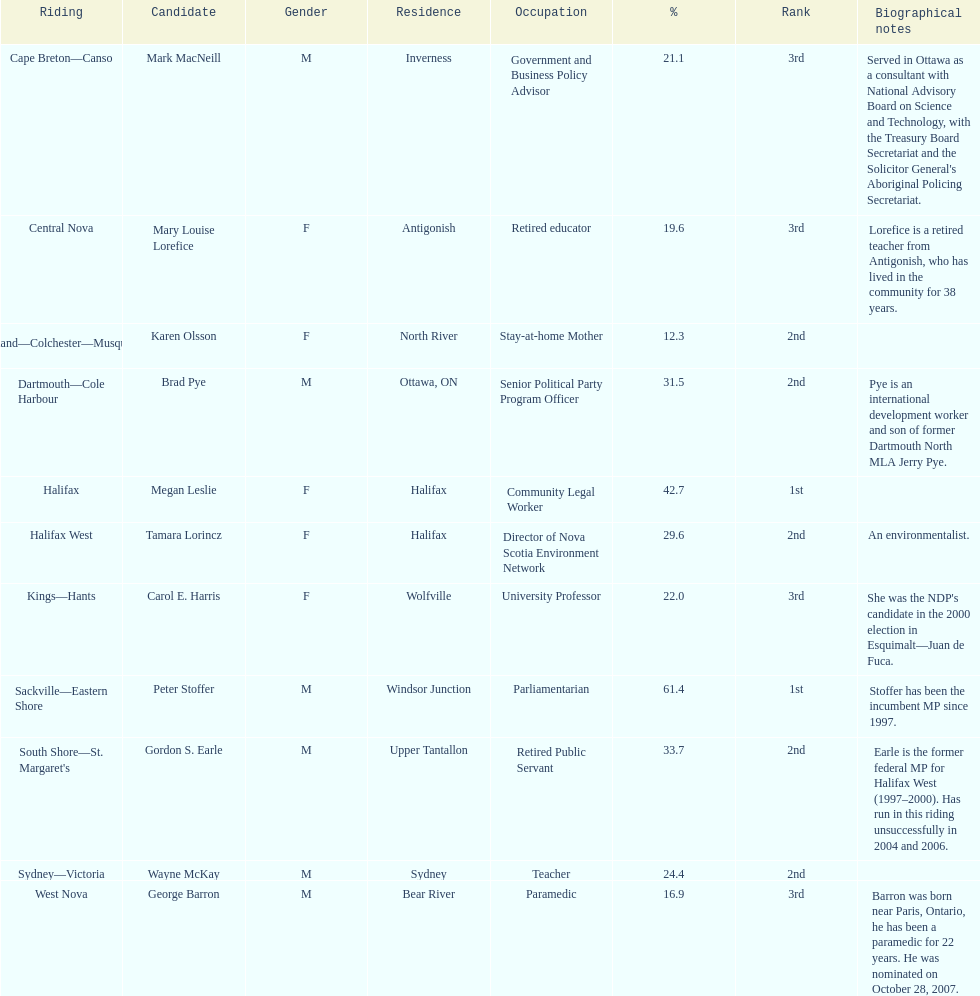Help me parse the entirety of this table. {'header': ['Riding', 'Candidate', 'Gender', 'Residence', 'Occupation', '%', 'Rank', 'Biographical notes'], 'rows': [['Cape Breton—Canso', 'Mark MacNeill', 'M', 'Inverness', 'Government and Business Policy Advisor', '21.1', '3rd', "Served in Ottawa as a consultant with National Advisory Board on Science and Technology, with the Treasury Board Secretariat and the Solicitor General's Aboriginal Policing Secretariat."], ['Central Nova', 'Mary Louise Lorefice', 'F', 'Antigonish', 'Retired educator', '19.6', '3rd', 'Lorefice is a retired teacher from Antigonish, who has lived in the community for 38 years.'], ['Cumberland—Colchester—Musquodoboit Valley', 'Karen Olsson', 'F', 'North River', 'Stay-at-home Mother', '12.3', '2nd', ''], ['Dartmouth—Cole Harbour', 'Brad Pye', 'M', 'Ottawa, ON', 'Senior Political Party Program Officer', '31.5', '2nd', 'Pye is an international development worker and son of former Dartmouth North MLA Jerry Pye.'], ['Halifax', 'Megan Leslie', 'F', 'Halifax', 'Community Legal Worker', '42.7', '1st', ''], ['Halifax West', 'Tamara Lorincz', 'F', 'Halifax', 'Director of Nova Scotia Environment Network', '29.6', '2nd', 'An environmentalist.'], ['Kings—Hants', 'Carol E. Harris', 'F', 'Wolfville', 'University Professor', '22.0', '3rd', "She was the NDP's candidate in the 2000 election in Esquimalt—Juan de Fuca."], ['Sackville—Eastern Shore', 'Peter Stoffer', 'M', 'Windsor Junction', 'Parliamentarian', '61.4', '1st', 'Stoffer has been the incumbent MP since 1997.'], ["South Shore—St. Margaret's", 'Gordon S. Earle', 'M', 'Upper Tantallon', 'Retired Public Servant', '33.7', '2nd', 'Earle is the former federal MP for Halifax West (1997–2000). Has run in this riding unsuccessfully in 2004 and 2006.'], ['Sydney—Victoria', 'Wayne McKay', 'M', 'Sydney', 'Teacher', '24.4', '2nd', ''], ['West Nova', 'George Barron', 'M', 'Bear River', 'Paramedic', '16.9', '3rd', 'Barron was born near Paris, Ontario, he has been a paramedic for 22 years. He was nominated on October 28, 2007.']]} How many candidates had more votes than tamara lorincz? 4. 